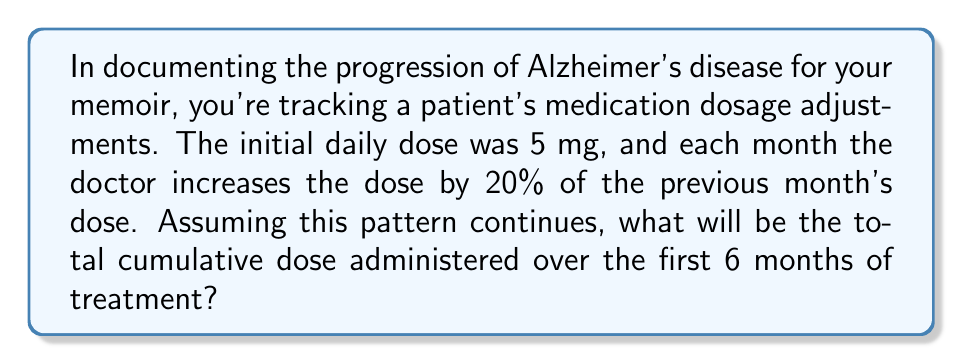Show me your answer to this math problem. Let's approach this step-by-step using a geometric series:

1) The initial dose (first term) is $a = 5$ mg/day.

2) The common ratio is $r = 1.20$, as each month's dose is 120% of the previous month's dose.

3) We need to find the sum of daily doses for 6 months. Each month has approximately 30 days, so we need 6 terms, each representing a month's total dose.

4) The geometric series for monthly doses is:
   $5, 5(1.20), 5(1.20)^2, 5(1.20)^3, 5(1.20)^4, 5(1.20)^5$

5) To get the total dose for each month, we multiply each term by 30 (days).

6) The sum of a geometric series is given by the formula:
   $S_n = \frac{a(1-r^n)}{1-r}$, where $a$ is the first term, $r$ is the common ratio, and $n$ is the number of terms.

7) In our case:
   $S_6 = \frac{5(1-(1.20)^6)}{1-1.20} \times 30$

8) Calculating:
   $S_6 = \frac{5(1-2.9860)}{-0.20} \times 30$
   $S_6 = \frac{5(-1.9860)}{-0.20} \times 30$
   $S_6 = 49.65 \times 30$
   $S_6 = 1489.5$

Therefore, the total cumulative dose over 6 months is 1489.5 mg.
Answer: 1489.5 mg 